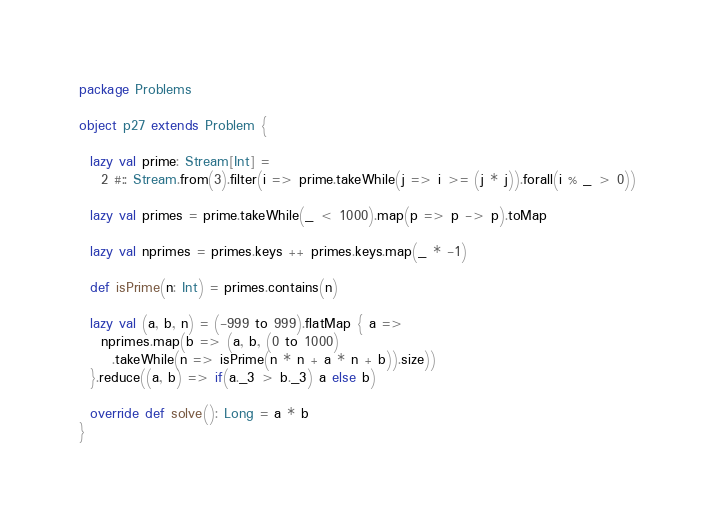<code> <loc_0><loc_0><loc_500><loc_500><_Scala_>package Problems

object p27 extends Problem {

  lazy val prime: Stream[Int] =
    2 #:: Stream.from(3).filter(i => prime.takeWhile(j => i >= (j * j)).forall(i % _ > 0))

  lazy val primes = prime.takeWhile(_ < 1000).map(p => p -> p).toMap

  lazy val nprimes = primes.keys ++ primes.keys.map(_ * -1)

  def isPrime(n: Int) = primes.contains(n)

  lazy val (a, b, n) = (-999 to 999).flatMap { a =>
    nprimes.map(b => (a, b, (0 to 1000)
      .takeWhile(n => isPrime(n * n + a * n + b)).size))
  }.reduce((a, b) => if(a._3 > b._3) a else b)

  override def solve(): Long = a * b
}
</code> 